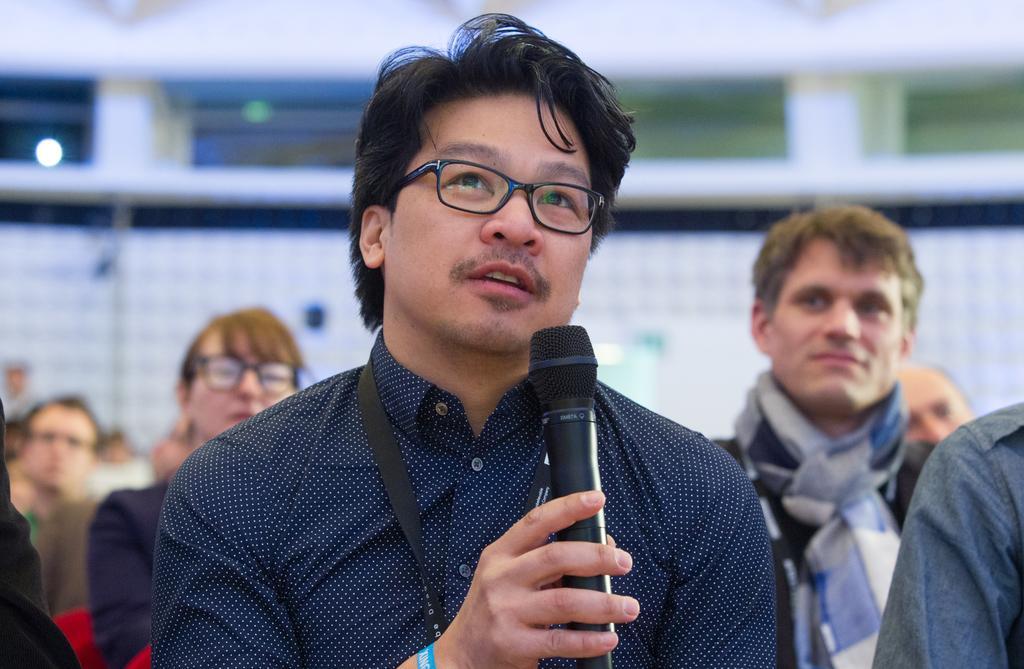Can you describe this image briefly? In a picture there are people sitting and in the middle one person is wearing a blue shirt and id card and holding a microphone and behind him there are people and at the right corner a person is wearing a scarf around his neck. 